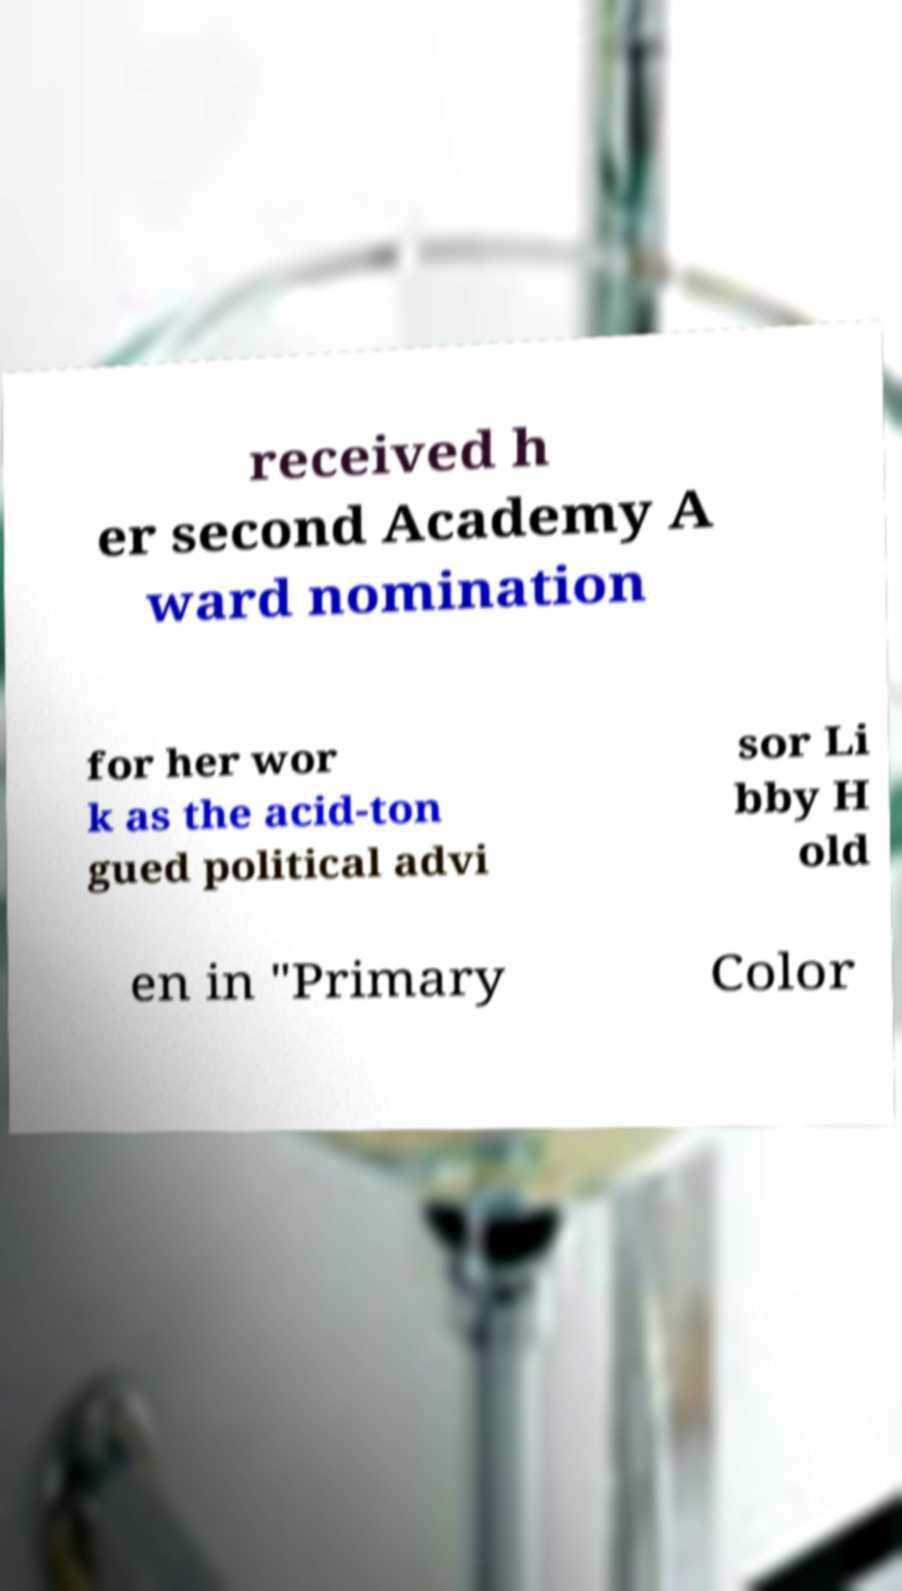Can you accurately transcribe the text from the provided image for me? received h er second Academy A ward nomination for her wor k as the acid-ton gued political advi sor Li bby H old en in "Primary Color 